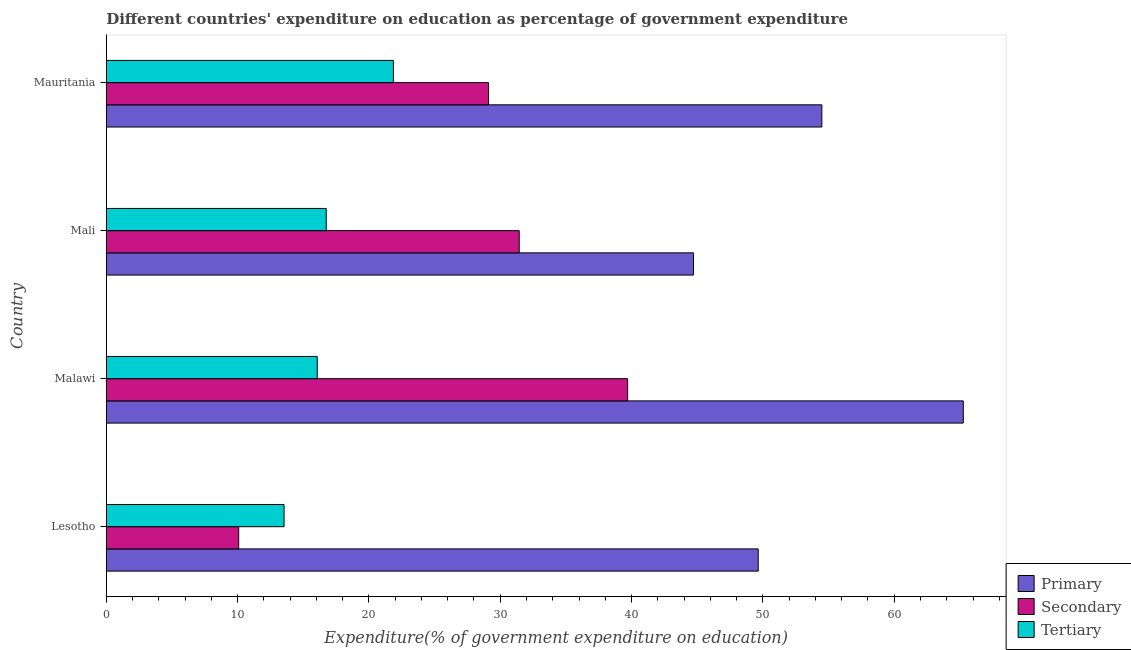How many different coloured bars are there?
Your answer should be very brief. 3. How many groups of bars are there?
Your answer should be compact. 4. How many bars are there on the 2nd tick from the top?
Give a very brief answer. 3. How many bars are there on the 1st tick from the bottom?
Offer a very short reply. 3. What is the label of the 3rd group of bars from the top?
Offer a very short reply. Malawi. In how many cases, is the number of bars for a given country not equal to the number of legend labels?
Ensure brevity in your answer.  0. What is the expenditure on tertiary education in Malawi?
Your answer should be compact. 16.06. Across all countries, what is the maximum expenditure on secondary education?
Provide a succinct answer. 39.7. Across all countries, what is the minimum expenditure on primary education?
Keep it short and to the point. 44.71. In which country was the expenditure on tertiary education maximum?
Provide a short and direct response. Mauritania. In which country was the expenditure on secondary education minimum?
Offer a very short reply. Lesotho. What is the total expenditure on primary education in the graph?
Give a very brief answer. 214.1. What is the difference between the expenditure on primary education in Mali and that in Mauritania?
Your response must be concise. -9.78. What is the difference between the expenditure on secondary education in Mali and the expenditure on primary education in Malawi?
Keep it short and to the point. -33.81. What is the average expenditure on primary education per country?
Provide a short and direct response. 53.52. What is the difference between the expenditure on primary education and expenditure on tertiary education in Mauritania?
Your answer should be compact. 32.62. What is the ratio of the expenditure on tertiary education in Lesotho to that in Mali?
Your answer should be compact. 0.81. What is the difference between the highest and the second highest expenditure on primary education?
Your answer should be compact. 10.77. What is the difference between the highest and the lowest expenditure on tertiary education?
Provide a short and direct response. 8.32. What does the 3rd bar from the top in Malawi represents?
Your answer should be very brief. Primary. What does the 3rd bar from the bottom in Mali represents?
Provide a short and direct response. Tertiary. What is the difference between two consecutive major ticks on the X-axis?
Provide a short and direct response. 10. How many legend labels are there?
Your answer should be very brief. 3. What is the title of the graph?
Ensure brevity in your answer.  Different countries' expenditure on education as percentage of government expenditure. Does "Private sector" appear as one of the legend labels in the graph?
Keep it short and to the point. No. What is the label or title of the X-axis?
Your response must be concise. Expenditure(% of government expenditure on education). What is the Expenditure(% of government expenditure on education) of Primary in Lesotho?
Make the answer very short. 49.64. What is the Expenditure(% of government expenditure on education) of Secondary in Lesotho?
Your answer should be compact. 10.08. What is the Expenditure(% of government expenditure on education) in Tertiary in Lesotho?
Keep it short and to the point. 13.54. What is the Expenditure(% of government expenditure on education) in Primary in Malawi?
Your answer should be compact. 65.26. What is the Expenditure(% of government expenditure on education) in Secondary in Malawi?
Keep it short and to the point. 39.7. What is the Expenditure(% of government expenditure on education) of Tertiary in Malawi?
Make the answer very short. 16.06. What is the Expenditure(% of government expenditure on education) of Primary in Mali?
Provide a succinct answer. 44.71. What is the Expenditure(% of government expenditure on education) of Secondary in Mali?
Keep it short and to the point. 31.44. What is the Expenditure(% of government expenditure on education) of Tertiary in Mali?
Make the answer very short. 16.75. What is the Expenditure(% of government expenditure on education) of Primary in Mauritania?
Your answer should be compact. 54.49. What is the Expenditure(% of government expenditure on education) in Secondary in Mauritania?
Give a very brief answer. 29.11. What is the Expenditure(% of government expenditure on education) in Tertiary in Mauritania?
Give a very brief answer. 21.86. Across all countries, what is the maximum Expenditure(% of government expenditure on education) of Primary?
Offer a very short reply. 65.26. Across all countries, what is the maximum Expenditure(% of government expenditure on education) in Secondary?
Provide a succinct answer. 39.7. Across all countries, what is the maximum Expenditure(% of government expenditure on education) of Tertiary?
Ensure brevity in your answer.  21.86. Across all countries, what is the minimum Expenditure(% of government expenditure on education) of Primary?
Your answer should be compact. 44.71. Across all countries, what is the minimum Expenditure(% of government expenditure on education) of Secondary?
Your answer should be very brief. 10.08. Across all countries, what is the minimum Expenditure(% of government expenditure on education) of Tertiary?
Ensure brevity in your answer.  13.54. What is the total Expenditure(% of government expenditure on education) in Primary in the graph?
Offer a very short reply. 214.1. What is the total Expenditure(% of government expenditure on education) in Secondary in the graph?
Your answer should be compact. 110.34. What is the total Expenditure(% of government expenditure on education) of Tertiary in the graph?
Offer a very short reply. 68.22. What is the difference between the Expenditure(% of government expenditure on education) in Primary in Lesotho and that in Malawi?
Your answer should be very brief. -15.61. What is the difference between the Expenditure(% of government expenditure on education) of Secondary in Lesotho and that in Malawi?
Offer a very short reply. -29.61. What is the difference between the Expenditure(% of government expenditure on education) of Tertiary in Lesotho and that in Malawi?
Give a very brief answer. -2.53. What is the difference between the Expenditure(% of government expenditure on education) of Primary in Lesotho and that in Mali?
Your response must be concise. 4.93. What is the difference between the Expenditure(% of government expenditure on education) of Secondary in Lesotho and that in Mali?
Provide a short and direct response. -21.36. What is the difference between the Expenditure(% of government expenditure on education) of Tertiary in Lesotho and that in Mali?
Keep it short and to the point. -3.21. What is the difference between the Expenditure(% of government expenditure on education) in Primary in Lesotho and that in Mauritania?
Make the answer very short. -4.85. What is the difference between the Expenditure(% of government expenditure on education) in Secondary in Lesotho and that in Mauritania?
Provide a short and direct response. -19.03. What is the difference between the Expenditure(% of government expenditure on education) in Tertiary in Lesotho and that in Mauritania?
Your answer should be very brief. -8.32. What is the difference between the Expenditure(% of government expenditure on education) in Primary in Malawi and that in Mali?
Your response must be concise. 20.54. What is the difference between the Expenditure(% of government expenditure on education) of Secondary in Malawi and that in Mali?
Ensure brevity in your answer.  8.25. What is the difference between the Expenditure(% of government expenditure on education) of Tertiary in Malawi and that in Mali?
Your answer should be very brief. -0.68. What is the difference between the Expenditure(% of government expenditure on education) of Primary in Malawi and that in Mauritania?
Offer a very short reply. 10.77. What is the difference between the Expenditure(% of government expenditure on education) in Secondary in Malawi and that in Mauritania?
Provide a short and direct response. 10.59. What is the difference between the Expenditure(% of government expenditure on education) of Tertiary in Malawi and that in Mauritania?
Provide a short and direct response. -5.8. What is the difference between the Expenditure(% of government expenditure on education) of Primary in Mali and that in Mauritania?
Offer a very short reply. -9.78. What is the difference between the Expenditure(% of government expenditure on education) of Secondary in Mali and that in Mauritania?
Offer a very short reply. 2.33. What is the difference between the Expenditure(% of government expenditure on education) of Tertiary in Mali and that in Mauritania?
Your response must be concise. -5.11. What is the difference between the Expenditure(% of government expenditure on education) of Primary in Lesotho and the Expenditure(% of government expenditure on education) of Secondary in Malawi?
Your response must be concise. 9.94. What is the difference between the Expenditure(% of government expenditure on education) in Primary in Lesotho and the Expenditure(% of government expenditure on education) in Tertiary in Malawi?
Keep it short and to the point. 33.58. What is the difference between the Expenditure(% of government expenditure on education) of Secondary in Lesotho and the Expenditure(% of government expenditure on education) of Tertiary in Malawi?
Offer a very short reply. -5.98. What is the difference between the Expenditure(% of government expenditure on education) of Primary in Lesotho and the Expenditure(% of government expenditure on education) of Secondary in Mali?
Your answer should be very brief. 18.2. What is the difference between the Expenditure(% of government expenditure on education) of Primary in Lesotho and the Expenditure(% of government expenditure on education) of Tertiary in Mali?
Ensure brevity in your answer.  32.89. What is the difference between the Expenditure(% of government expenditure on education) in Secondary in Lesotho and the Expenditure(% of government expenditure on education) in Tertiary in Mali?
Offer a terse response. -6.66. What is the difference between the Expenditure(% of government expenditure on education) of Primary in Lesotho and the Expenditure(% of government expenditure on education) of Secondary in Mauritania?
Your response must be concise. 20.53. What is the difference between the Expenditure(% of government expenditure on education) in Primary in Lesotho and the Expenditure(% of government expenditure on education) in Tertiary in Mauritania?
Provide a short and direct response. 27.78. What is the difference between the Expenditure(% of government expenditure on education) of Secondary in Lesotho and the Expenditure(% of government expenditure on education) of Tertiary in Mauritania?
Your response must be concise. -11.78. What is the difference between the Expenditure(% of government expenditure on education) in Primary in Malawi and the Expenditure(% of government expenditure on education) in Secondary in Mali?
Offer a very short reply. 33.81. What is the difference between the Expenditure(% of government expenditure on education) of Primary in Malawi and the Expenditure(% of government expenditure on education) of Tertiary in Mali?
Keep it short and to the point. 48.51. What is the difference between the Expenditure(% of government expenditure on education) in Secondary in Malawi and the Expenditure(% of government expenditure on education) in Tertiary in Mali?
Ensure brevity in your answer.  22.95. What is the difference between the Expenditure(% of government expenditure on education) of Primary in Malawi and the Expenditure(% of government expenditure on education) of Secondary in Mauritania?
Make the answer very short. 36.14. What is the difference between the Expenditure(% of government expenditure on education) of Primary in Malawi and the Expenditure(% of government expenditure on education) of Tertiary in Mauritania?
Your answer should be compact. 43.39. What is the difference between the Expenditure(% of government expenditure on education) in Secondary in Malawi and the Expenditure(% of government expenditure on education) in Tertiary in Mauritania?
Provide a succinct answer. 17.84. What is the difference between the Expenditure(% of government expenditure on education) in Primary in Mali and the Expenditure(% of government expenditure on education) in Secondary in Mauritania?
Make the answer very short. 15.6. What is the difference between the Expenditure(% of government expenditure on education) of Primary in Mali and the Expenditure(% of government expenditure on education) of Tertiary in Mauritania?
Make the answer very short. 22.85. What is the difference between the Expenditure(% of government expenditure on education) of Secondary in Mali and the Expenditure(% of government expenditure on education) of Tertiary in Mauritania?
Your answer should be compact. 9.58. What is the average Expenditure(% of government expenditure on education) of Primary per country?
Your response must be concise. 53.52. What is the average Expenditure(% of government expenditure on education) of Secondary per country?
Your answer should be very brief. 27.58. What is the average Expenditure(% of government expenditure on education) in Tertiary per country?
Give a very brief answer. 17.05. What is the difference between the Expenditure(% of government expenditure on education) of Primary and Expenditure(% of government expenditure on education) of Secondary in Lesotho?
Your response must be concise. 39.56. What is the difference between the Expenditure(% of government expenditure on education) in Primary and Expenditure(% of government expenditure on education) in Tertiary in Lesotho?
Ensure brevity in your answer.  36.1. What is the difference between the Expenditure(% of government expenditure on education) in Secondary and Expenditure(% of government expenditure on education) in Tertiary in Lesotho?
Provide a short and direct response. -3.45. What is the difference between the Expenditure(% of government expenditure on education) in Primary and Expenditure(% of government expenditure on education) in Secondary in Malawi?
Offer a terse response. 25.56. What is the difference between the Expenditure(% of government expenditure on education) of Primary and Expenditure(% of government expenditure on education) of Tertiary in Malawi?
Offer a very short reply. 49.19. What is the difference between the Expenditure(% of government expenditure on education) of Secondary and Expenditure(% of government expenditure on education) of Tertiary in Malawi?
Your answer should be compact. 23.63. What is the difference between the Expenditure(% of government expenditure on education) in Primary and Expenditure(% of government expenditure on education) in Secondary in Mali?
Your answer should be compact. 13.27. What is the difference between the Expenditure(% of government expenditure on education) of Primary and Expenditure(% of government expenditure on education) of Tertiary in Mali?
Ensure brevity in your answer.  27.96. What is the difference between the Expenditure(% of government expenditure on education) of Secondary and Expenditure(% of government expenditure on education) of Tertiary in Mali?
Keep it short and to the point. 14.7. What is the difference between the Expenditure(% of government expenditure on education) in Primary and Expenditure(% of government expenditure on education) in Secondary in Mauritania?
Offer a very short reply. 25.38. What is the difference between the Expenditure(% of government expenditure on education) of Primary and Expenditure(% of government expenditure on education) of Tertiary in Mauritania?
Keep it short and to the point. 32.62. What is the difference between the Expenditure(% of government expenditure on education) of Secondary and Expenditure(% of government expenditure on education) of Tertiary in Mauritania?
Provide a succinct answer. 7.25. What is the ratio of the Expenditure(% of government expenditure on education) in Primary in Lesotho to that in Malawi?
Provide a short and direct response. 0.76. What is the ratio of the Expenditure(% of government expenditure on education) of Secondary in Lesotho to that in Malawi?
Your answer should be compact. 0.25. What is the ratio of the Expenditure(% of government expenditure on education) in Tertiary in Lesotho to that in Malawi?
Offer a terse response. 0.84. What is the ratio of the Expenditure(% of government expenditure on education) in Primary in Lesotho to that in Mali?
Keep it short and to the point. 1.11. What is the ratio of the Expenditure(% of government expenditure on education) of Secondary in Lesotho to that in Mali?
Ensure brevity in your answer.  0.32. What is the ratio of the Expenditure(% of government expenditure on education) of Tertiary in Lesotho to that in Mali?
Offer a terse response. 0.81. What is the ratio of the Expenditure(% of government expenditure on education) in Primary in Lesotho to that in Mauritania?
Offer a very short reply. 0.91. What is the ratio of the Expenditure(% of government expenditure on education) of Secondary in Lesotho to that in Mauritania?
Ensure brevity in your answer.  0.35. What is the ratio of the Expenditure(% of government expenditure on education) in Tertiary in Lesotho to that in Mauritania?
Give a very brief answer. 0.62. What is the ratio of the Expenditure(% of government expenditure on education) of Primary in Malawi to that in Mali?
Your answer should be compact. 1.46. What is the ratio of the Expenditure(% of government expenditure on education) in Secondary in Malawi to that in Mali?
Offer a very short reply. 1.26. What is the ratio of the Expenditure(% of government expenditure on education) of Tertiary in Malawi to that in Mali?
Offer a terse response. 0.96. What is the ratio of the Expenditure(% of government expenditure on education) of Primary in Malawi to that in Mauritania?
Provide a short and direct response. 1.2. What is the ratio of the Expenditure(% of government expenditure on education) in Secondary in Malawi to that in Mauritania?
Your answer should be very brief. 1.36. What is the ratio of the Expenditure(% of government expenditure on education) of Tertiary in Malawi to that in Mauritania?
Your answer should be compact. 0.73. What is the ratio of the Expenditure(% of government expenditure on education) of Primary in Mali to that in Mauritania?
Provide a short and direct response. 0.82. What is the ratio of the Expenditure(% of government expenditure on education) in Secondary in Mali to that in Mauritania?
Keep it short and to the point. 1.08. What is the ratio of the Expenditure(% of government expenditure on education) of Tertiary in Mali to that in Mauritania?
Give a very brief answer. 0.77. What is the difference between the highest and the second highest Expenditure(% of government expenditure on education) of Primary?
Your answer should be compact. 10.77. What is the difference between the highest and the second highest Expenditure(% of government expenditure on education) of Secondary?
Your response must be concise. 8.25. What is the difference between the highest and the second highest Expenditure(% of government expenditure on education) in Tertiary?
Give a very brief answer. 5.11. What is the difference between the highest and the lowest Expenditure(% of government expenditure on education) in Primary?
Provide a succinct answer. 20.54. What is the difference between the highest and the lowest Expenditure(% of government expenditure on education) of Secondary?
Your answer should be very brief. 29.61. What is the difference between the highest and the lowest Expenditure(% of government expenditure on education) in Tertiary?
Provide a succinct answer. 8.32. 